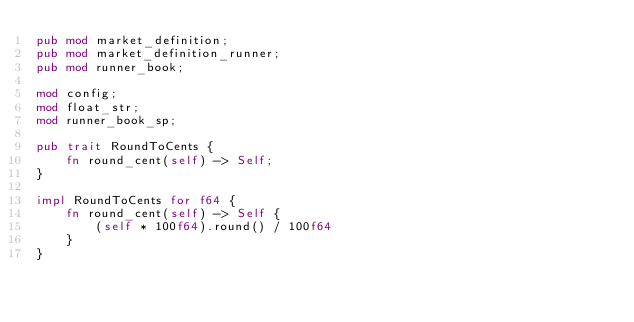Convert code to text. <code><loc_0><loc_0><loc_500><loc_500><_Rust_>pub mod market_definition;
pub mod market_definition_runner;
pub mod runner_book;

mod config;
mod float_str;
mod runner_book_sp;

pub trait RoundToCents {
    fn round_cent(self) -> Self;
}

impl RoundToCents for f64 {
    fn round_cent(self) -> Self {
        (self * 100f64).round() / 100f64
    }
}
</code> 